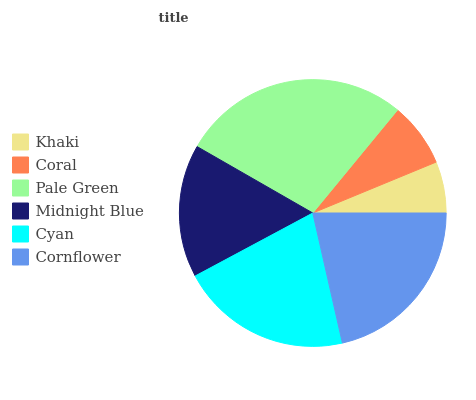Is Khaki the minimum?
Answer yes or no. Yes. Is Pale Green the maximum?
Answer yes or no. Yes. Is Coral the minimum?
Answer yes or no. No. Is Coral the maximum?
Answer yes or no. No. Is Coral greater than Khaki?
Answer yes or no. Yes. Is Khaki less than Coral?
Answer yes or no. Yes. Is Khaki greater than Coral?
Answer yes or no. No. Is Coral less than Khaki?
Answer yes or no. No. Is Cyan the high median?
Answer yes or no. Yes. Is Midnight Blue the low median?
Answer yes or no. Yes. Is Midnight Blue the high median?
Answer yes or no. No. Is Cyan the low median?
Answer yes or no. No. 